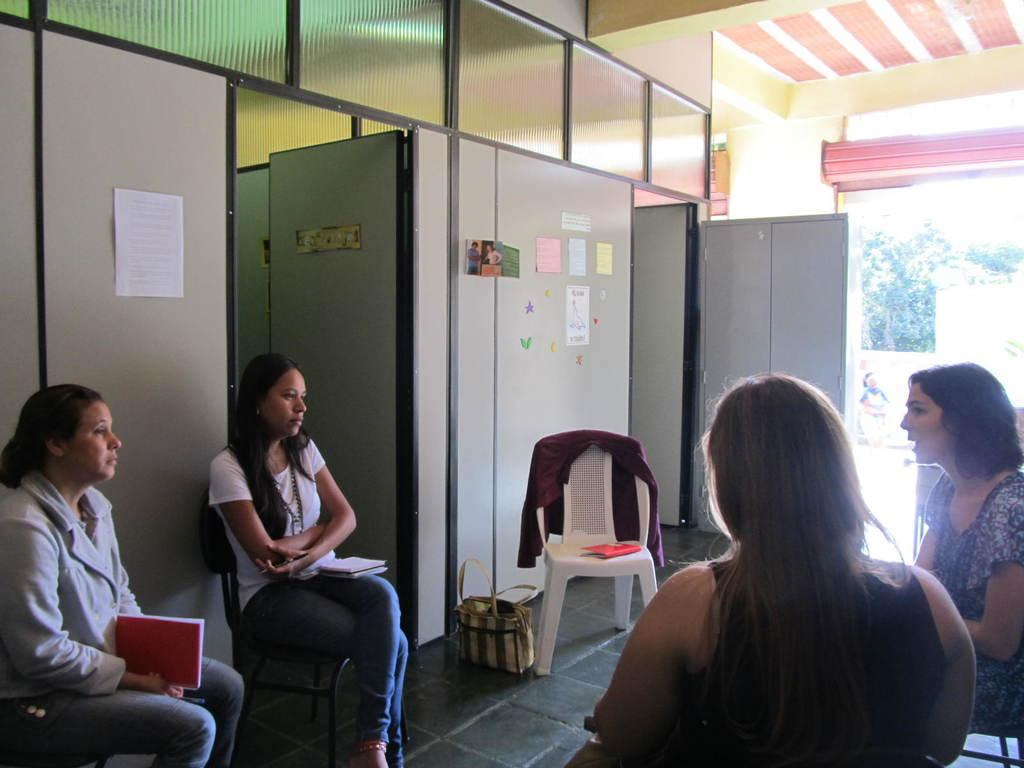How many women are present in the image? There are four women in the image. What are the women doing in the image? The women are sitting on chairs. Can you describe any objects on the floor in the image? There is a bag on the floor. What type of furniture can be seen in the image? There is a cupboard in the image. What type of decorations are present in the image? There are posters in the image. Are there any doors visible in the image? Yes, there are doors in the image. What can be seen in the background of the image? Trees are visible in the background of the image. What type of bead is being used to decorate the eyes of the women in the image? There is no mention of beads or any eye decoration in the image. The women's eyes are not described in the provided facts. 